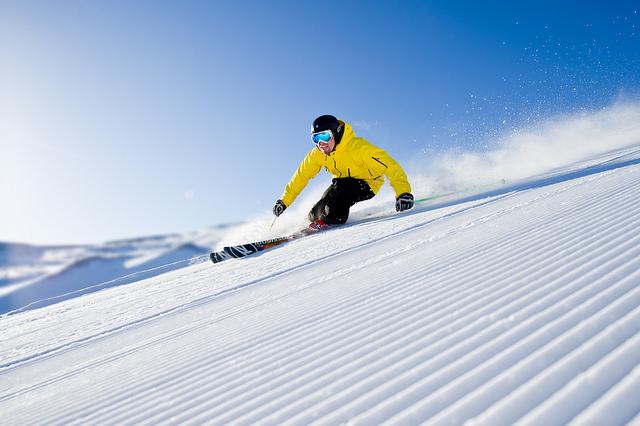Does the snow look rough?
Be succinct. Yes. Is the man skiing or snowboarding?
Give a very brief answer. Skiing. What color is this jacket?
Concise answer only. Yellow. 